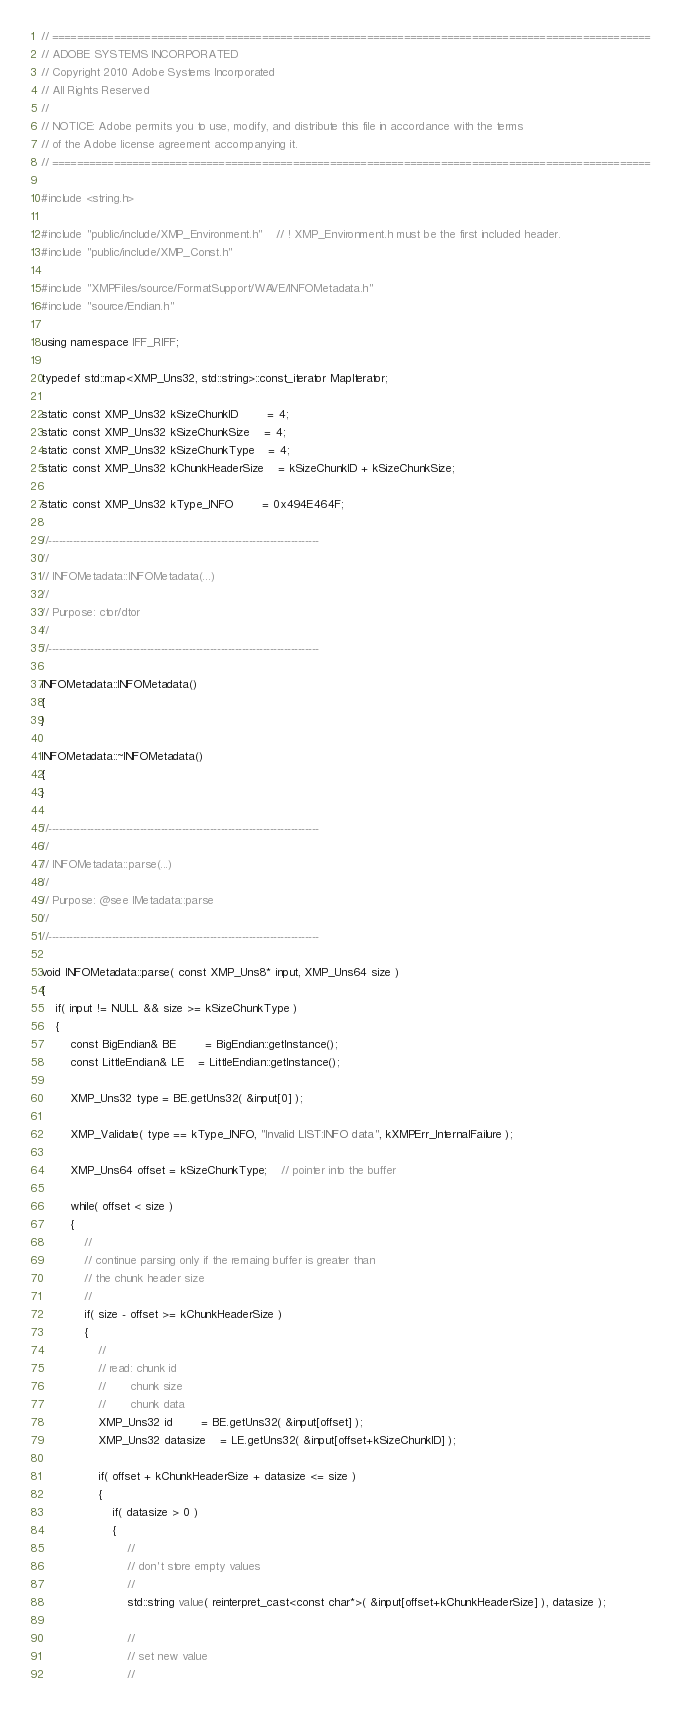Convert code to text. <code><loc_0><loc_0><loc_500><loc_500><_C++_>// =================================================================================================
// ADOBE SYSTEMS INCORPORATED
// Copyright 2010 Adobe Systems Incorporated
// All Rights Reserved
//
// NOTICE: Adobe permits you to use, modify, and distribute this file in accordance with the terms
// of the Adobe license agreement accompanying it.
// =================================================================================================

#include <string.h>

#include "public/include/XMP_Environment.h"	// ! XMP_Environment.h must be the first included header.
#include "public/include/XMP_Const.h"

#include "XMPFiles/source/FormatSupport/WAVE/INFOMetadata.h"
#include "source/Endian.h"

using namespace IFF_RIFF;

typedef std::map<XMP_Uns32, std::string>::const_iterator MapIterator;

static const XMP_Uns32 kSizeChunkID		= 4;
static const XMP_Uns32 kSizeChunkSize	= 4;
static const XMP_Uns32 kSizeChunkType	= 4;
static const XMP_Uns32 kChunkHeaderSize	= kSizeChunkID + kSizeChunkSize;

static const XMP_Uns32 kType_INFO		= 0x494E464F;

//-----------------------------------------------------------------------------
// 
// INFOMetadata::INFOMetadata(...)
// 
// Purpose: ctor/dtor
// 
//-----------------------------------------------------------------------------

INFOMetadata::INFOMetadata()
{
}

INFOMetadata::~INFOMetadata()
{
}

//-----------------------------------------------------------------------------
// 
// INFOMetadata::parse(...)
// 
// Purpose: @see IMetadata::parse
// 
//-----------------------------------------------------------------------------

void INFOMetadata::parse( const XMP_Uns8* input, XMP_Uns64 size )
{
	if( input != NULL && size >= kSizeChunkType )
	{
		const BigEndian& BE		= BigEndian::getInstance();
		const LittleEndian& LE	= LittleEndian::getInstance();

		XMP_Uns32 type = BE.getUns32( &input[0] );

		XMP_Validate( type == kType_INFO, "Invalid LIST:INFO data", kXMPErr_InternalFailure );

		XMP_Uns64 offset = kSizeChunkType;	// pointer into the buffer

		while( offset < size )
		{
			//
			// continue parsing only if the remaing buffer is greater than
			// the chunk header size
			//
			if( size - offset >= kChunkHeaderSize )
			{
				//
				// read: chunk id
				//		 chunk size
				//		 chunk data
				XMP_Uns32 id		= BE.getUns32( &input[offset] );
				XMP_Uns32 datasize	= LE.getUns32( &input[offset+kSizeChunkID] );

				if( offset + kChunkHeaderSize + datasize <= size )
				{
					if( datasize > 0 )
					{
						//
						// don't store empty values
						//
						std::string value( reinterpret_cast<const char*>( &input[offset+kChunkHeaderSize] ), datasize );

						//
						// set new value
						//</code> 